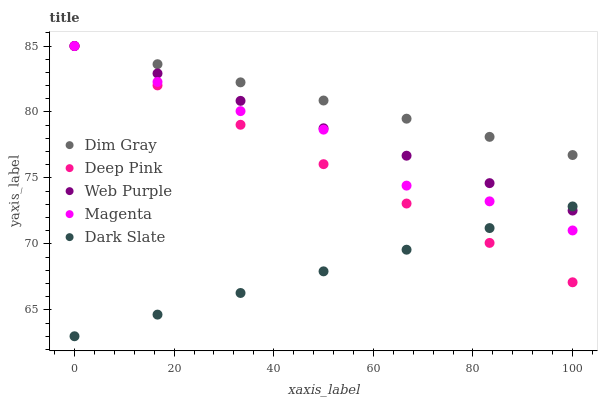Does Dark Slate have the minimum area under the curve?
Answer yes or no. Yes. Does Dim Gray have the maximum area under the curve?
Answer yes or no. Yes. Does Web Purple have the minimum area under the curve?
Answer yes or no. No. Does Web Purple have the maximum area under the curve?
Answer yes or no. No. Is Web Purple the smoothest?
Answer yes or no. Yes. Is Magenta the roughest?
Answer yes or no. Yes. Is Dim Gray the smoothest?
Answer yes or no. No. Is Dim Gray the roughest?
Answer yes or no. No. Does Dark Slate have the lowest value?
Answer yes or no. Yes. Does Web Purple have the lowest value?
Answer yes or no. No. Does Deep Pink have the highest value?
Answer yes or no. Yes. Is Dark Slate less than Dim Gray?
Answer yes or no. Yes. Is Dim Gray greater than Dark Slate?
Answer yes or no. Yes. Does Web Purple intersect Dim Gray?
Answer yes or no. Yes. Is Web Purple less than Dim Gray?
Answer yes or no. No. Is Web Purple greater than Dim Gray?
Answer yes or no. No. Does Dark Slate intersect Dim Gray?
Answer yes or no. No. 